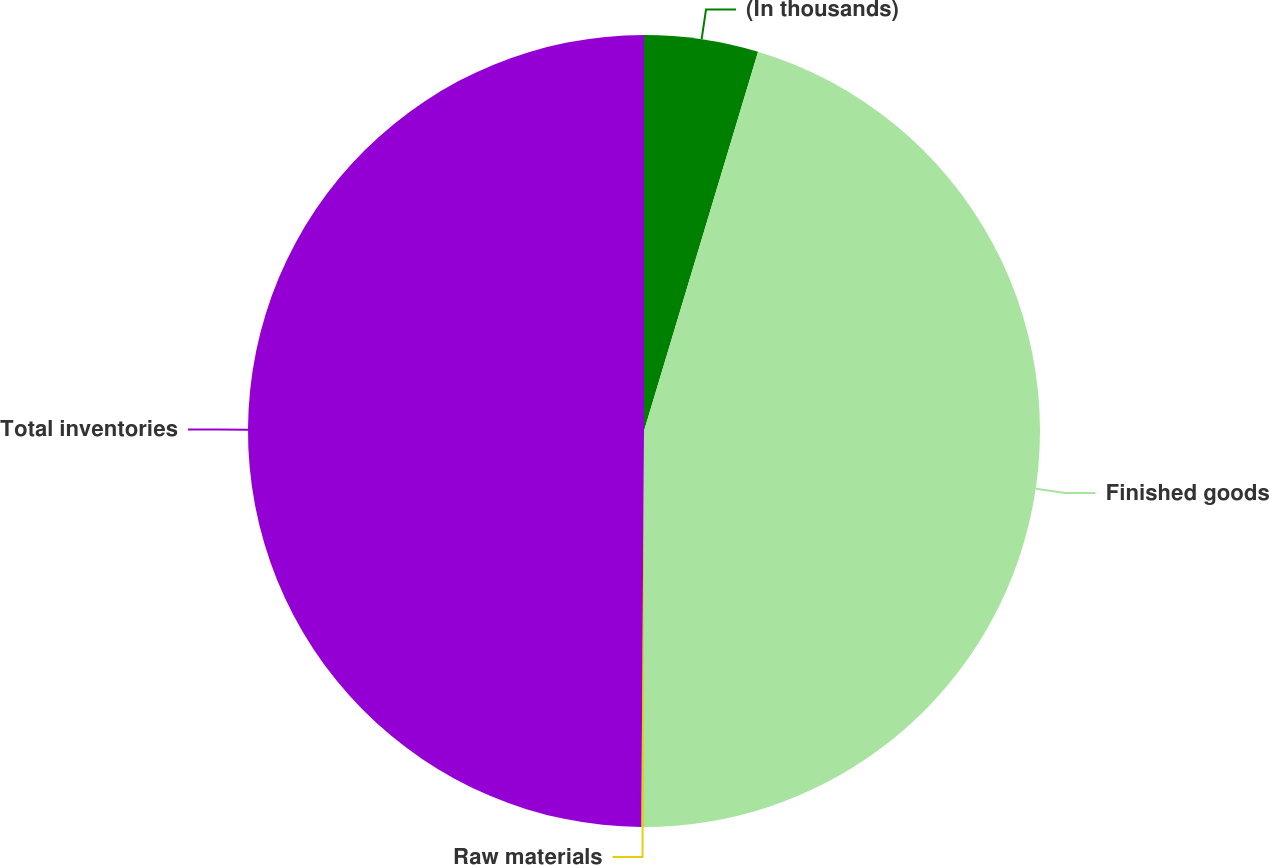<chart> <loc_0><loc_0><loc_500><loc_500><pie_chart><fcel>(In thousands)<fcel>Finished goods<fcel>Raw materials<fcel>Total inventories<nl><fcel>4.65%<fcel>45.35%<fcel>0.11%<fcel>49.89%<nl></chart> 